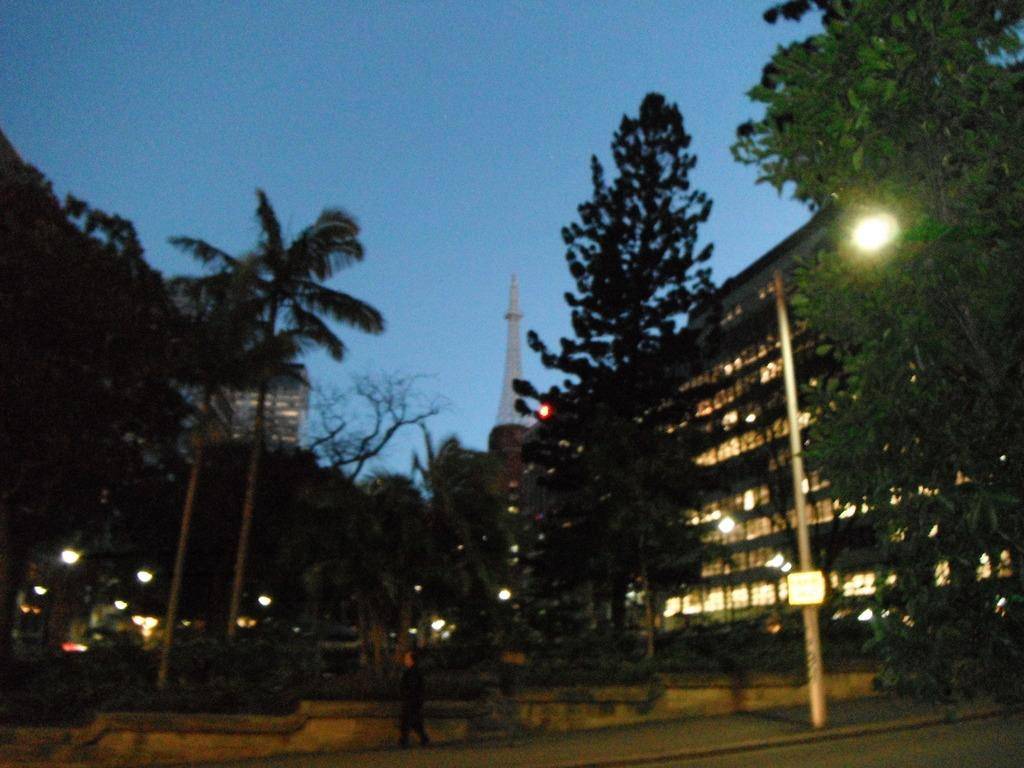What is the person in the image doing? There is a person walking in the image. What can be seen in the image besides the person? There is a pole, trees, buildings, a tower, lights, and the sky visible in the image. Can you describe the background of the image? The background of the image includes buildings, a tower, lights, and the sky. What type of vegetation is present in the image? There are trees in the image. What does the smell of the trees in the image indicate? There is no mention of a smell in the image, so it cannot be determined what the trees might smell like. 